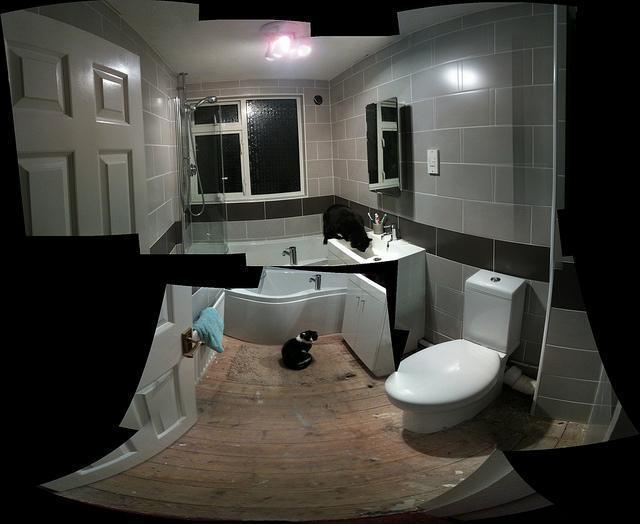How many baby elephants are pictured?
Give a very brief answer. 0. 